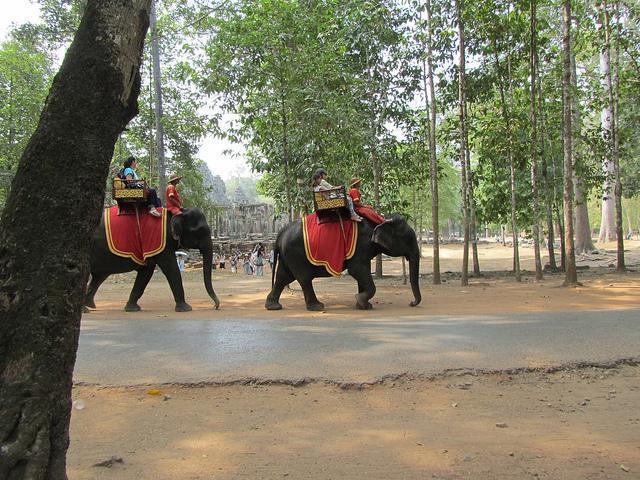How many elephants are visible?
Give a very brief answer. 2. 